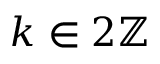<formula> <loc_0><loc_0><loc_500><loc_500>k \in 2 { \mathbb { Z } }</formula> 